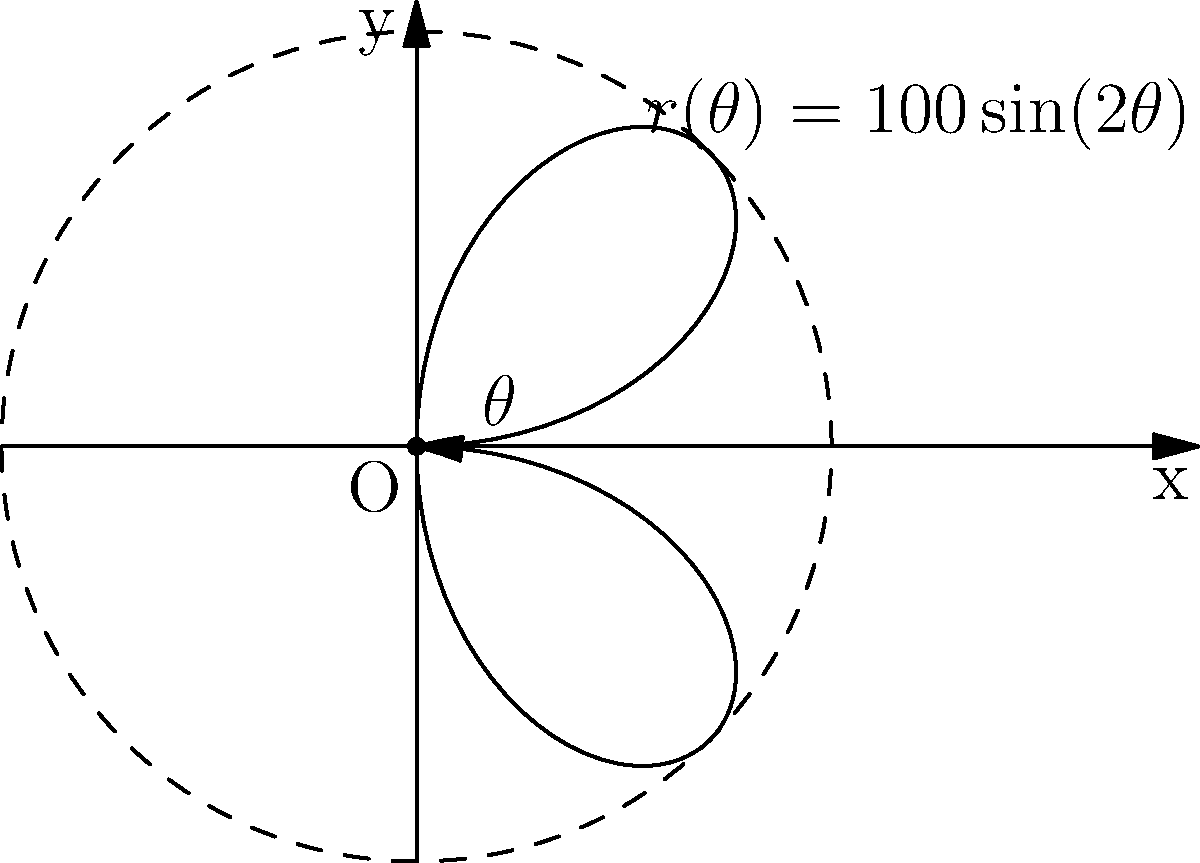As an experienced archer, you're analyzing the trajectory of an arrow in windy conditions. The path can be modeled using the polar equation $r(\theta) = 100\sin(2\theta)$, where $r$ is in meters and $\theta$ is in radians. At what angle $\theta$ (in radians) does the arrow reach its maximum distance from the origin? To find the maximum distance from the origin, we need to follow these steps:

1) The maximum distance occurs when $\frac{dr}{d\theta} = 0$.

2) Differentiate $r(\theta)$ with respect to $\theta$:
   $$\frac{dr}{d\theta} = 100 \cdot 2 \cos(2\theta) = 200\cos(2\theta)$$

3) Set this equal to zero and solve for $\theta$:
   $$200\cos(2\theta) = 0$$
   $$\cos(2\theta) = 0$$

4) The solutions to this equation are:
   $$2\theta = \frac{\pi}{2}, \frac{3\pi}{2}, \frac{5\pi}{2}, ...$$

5) Solving for $\theta$:
   $$\theta = \frac{\pi}{4}, \frac{3\pi}{4}, \frac{5\pi}{4}, ...$$

6) The first positive solution in the range $[0, \pi]$ is $\frac{\pi}{4}$.

Therefore, the arrow reaches its maximum distance from the origin when $\theta = \frac{\pi}{4}$ radians.
Answer: $\frac{\pi}{4}$ radians 